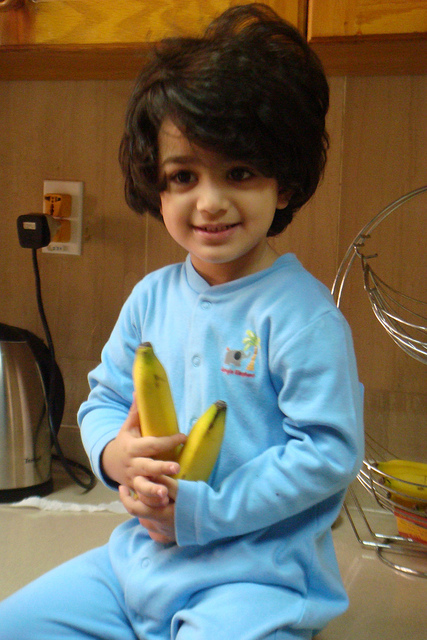Can you provide a detailed description of the child's outfit and expression? The child is dressed in a delightful baby blue onesie made of soft material, featuring a playful design on the chest, possibly an embroidered or printed character. The onesie appears comfortable and cozy, perfect for wearing at home. The child’s hair is dark, slightly tousled, and frames their face charmingly. Their expression is one of joy and contentment, likely due to the playful activity they are engaged in or the cozy kitchen environment. The warm smile and the gentle grip on the bananas suggest a moment of simple happiness and innocence. Imagine if the child was hosting a cooking show. What kind of recipes might they share? If the child were hosting a cooking show, they might share fun and easy recipes suitable for kids. Here are some imaginative recipes they might introduce:

1. **Banana Delight Smoothie:** A blend of ripe bananas, milk, a spoonful of honey, and a handful of strawberries, topped with a swirl of whipped cream.

2. **Fruit Faces:** A creative plate with banana slices, berries, and apple pieces arranged to form happy faces, encouraging children to eat more fruit.

3. **Yogurt Banana Splits:** Sliced bananas topped with yogurt, granola, and a drizzle of honey, resembling a healthy version of the traditional banana split.

4. **Banana Pancakes:** Easy-to-make mini pancakes using mashed bananas in the batter, served with a sprinkle of cinnamon and a side of maple syrup.

5. **Banana Boats:** Halved bananas filled with peanut butter and topped with chocolate chips, then chilled for a fun, sweet snack.

The child’s excitement and enthusiasm would make the show engaging and entertaining for young viewers, promoting healthy eating habits in a fun and interactive way. Imagine a scenario where the child is an astronaut on a space station. How would the scene change? If the child were an astronaut on a space station, the scene would transform dramatically. The warm, wooden kitchen backdrop would be replaced by the sleek, futuristic interior of a space station, with metallic surfaces and advanced technology. The child’s onesie might change into a miniature astronaut suit, complete with space agency insignias.

The bananas, now floating weightlessly around the child, would create a playful and surreal effect. The basket might contain other space-ready fruits and snacks, specially packaged for zero-gravity consumption. The wall socket could be replaced by a control panel with various buttons and lights, indicating the advanced systems of the space station.

The child’s expression of joy would remain, but now it would reflect the excitement of floating in zero gravity, possibly reaching out to grab a floating banana. Their playful interaction with the floating objects would highlight the wonders and fun aspects of living in space, combining the innocence of childhood with the excitement of space exploration. 